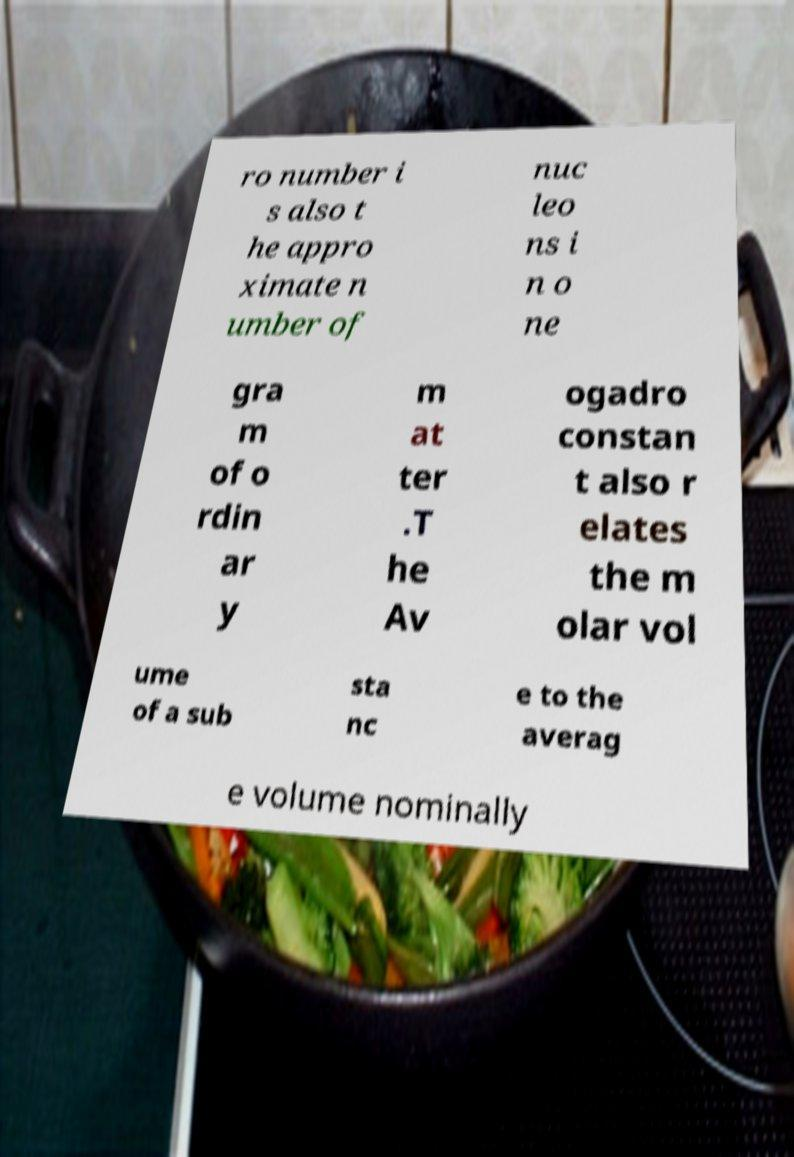Can you accurately transcribe the text from the provided image for me? ro number i s also t he appro ximate n umber of nuc leo ns i n o ne gra m of o rdin ar y m at ter .T he Av ogadro constan t also r elates the m olar vol ume of a sub sta nc e to the averag e volume nominally 